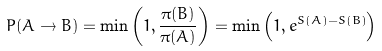<formula> <loc_0><loc_0><loc_500><loc_500>P ( A \to B ) = \min \left ( 1 , \frac { \pi ( B ) } { \pi ( A ) } \right ) = \min \left ( 1 , e ^ { S ( A ) - S ( B ) } \right )</formula> 